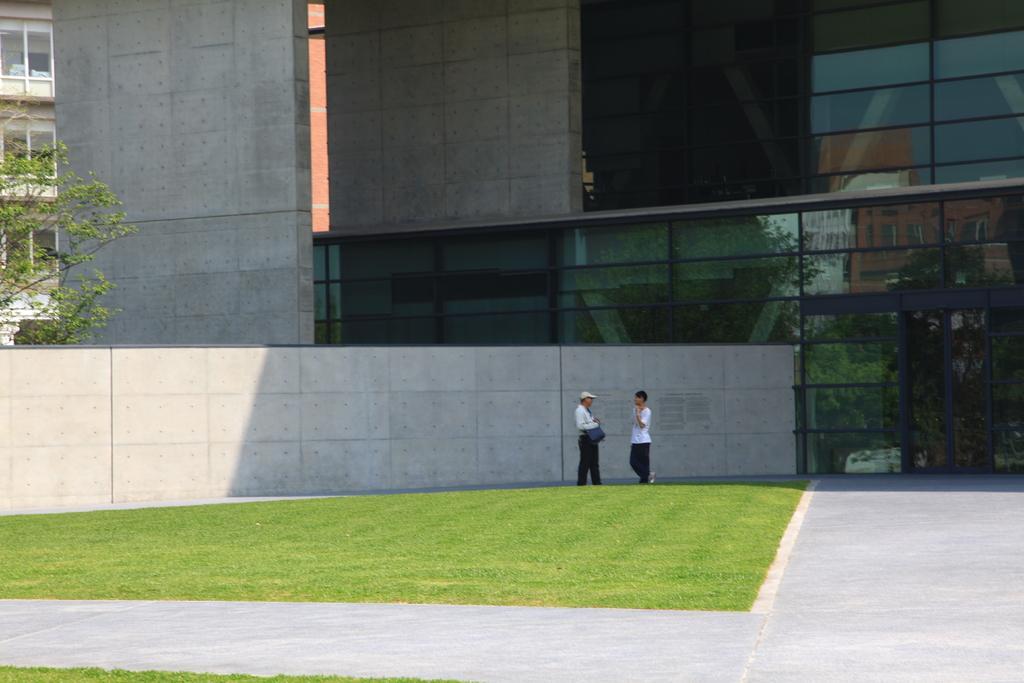Please provide a concise description of this image. In this image, I see a path over here and grass and I can also see 2 persons over here. In the background I can see the wall, a building and a tree. 